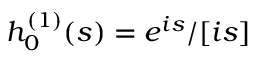Convert formula to latex. <formula><loc_0><loc_0><loc_500><loc_500>h _ { 0 } ^ { ( 1 ) } ( s ) = e ^ { i s } / [ i s ]</formula> 